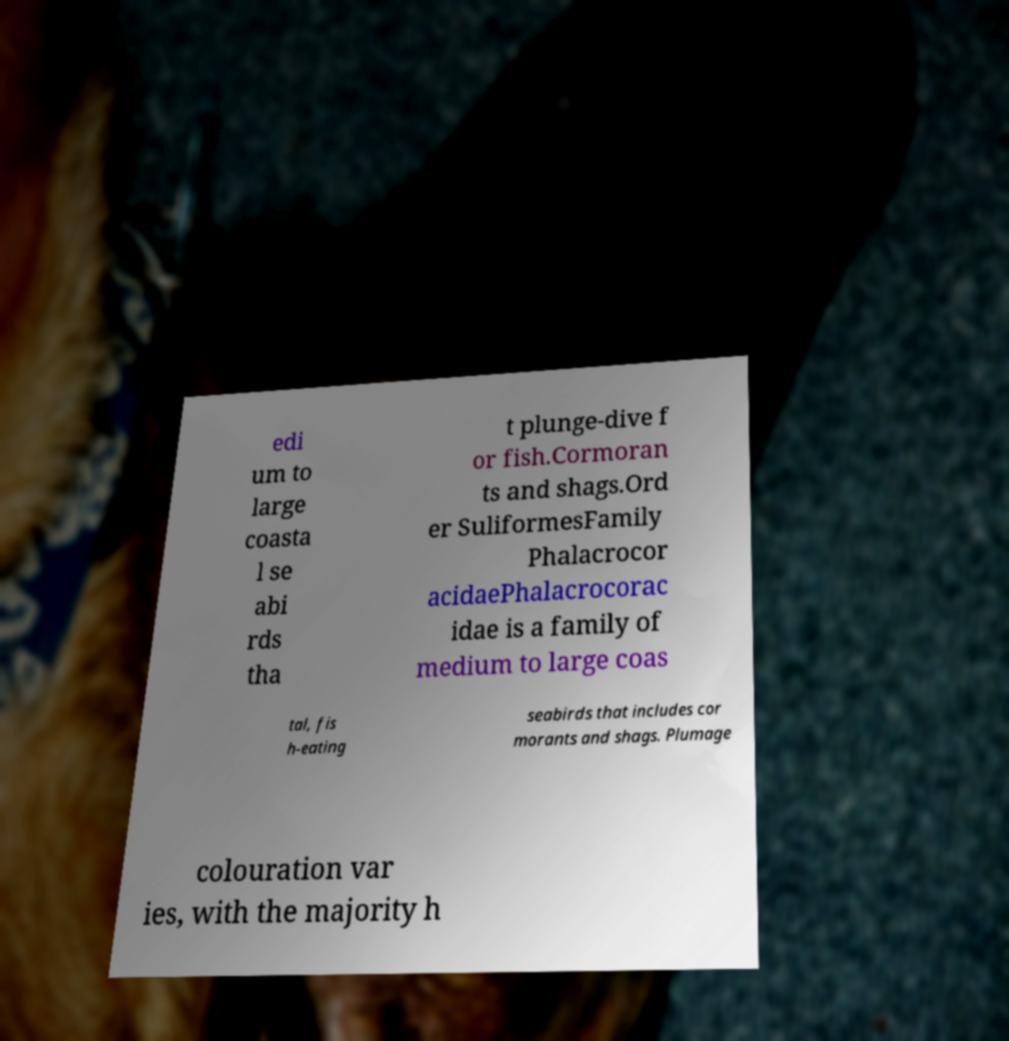Could you assist in decoding the text presented in this image and type it out clearly? edi um to large coasta l se abi rds tha t plunge-dive f or fish.Cormoran ts and shags.Ord er SuliformesFamily Phalacrocor acidaePhalacrocorac idae is a family of medium to large coas tal, fis h-eating seabirds that includes cor morants and shags. Plumage colouration var ies, with the majority h 